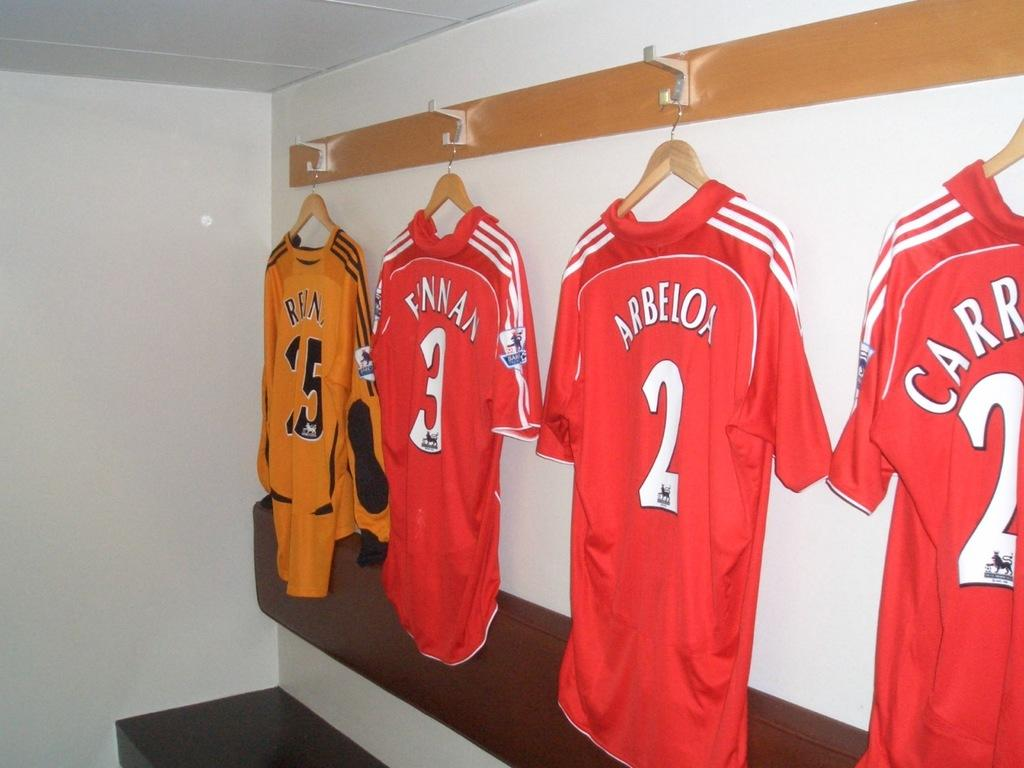Provide a one-sentence caption for the provided image. Several sports jerseys are hanging up in a room and one of them says Arbeloa. 